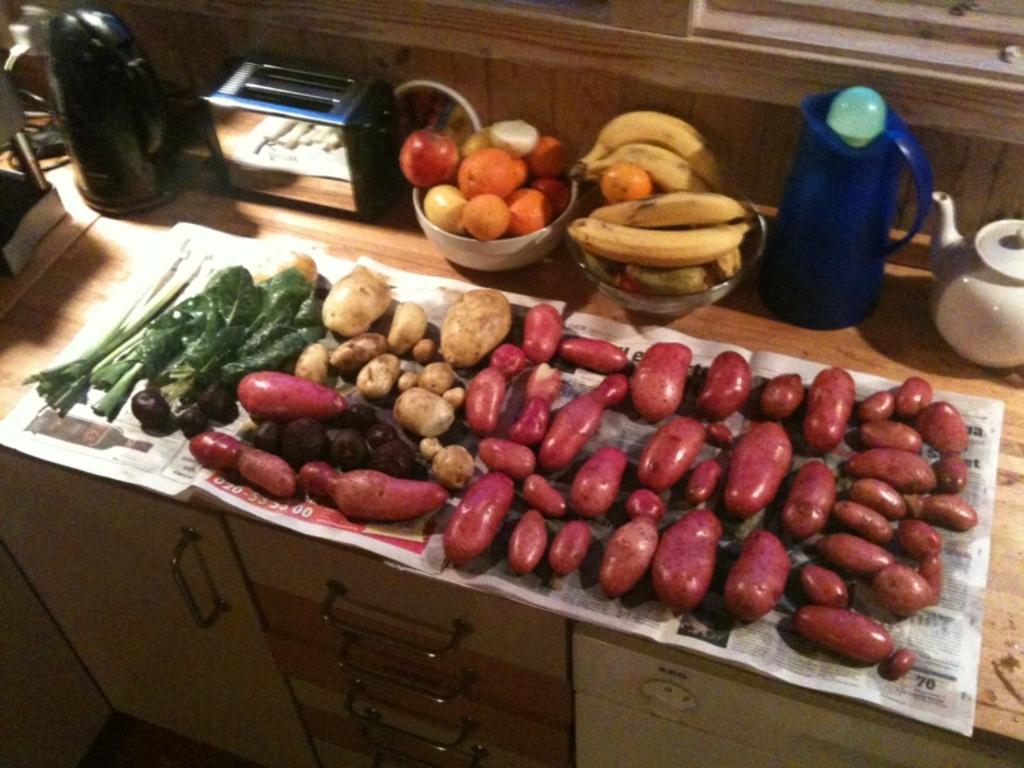Please provide a concise description of this image. On the table I can see the potatoes, brinjals and other vegetables. Beside that I can see the apples, oranges, bananas in a bowls. Beside that I can see the toaster. Beside that there is a jar. On the left I can see the water jug and tea jar. At the top I can see the windows frame. At the bottom I can see the drawers and door. 